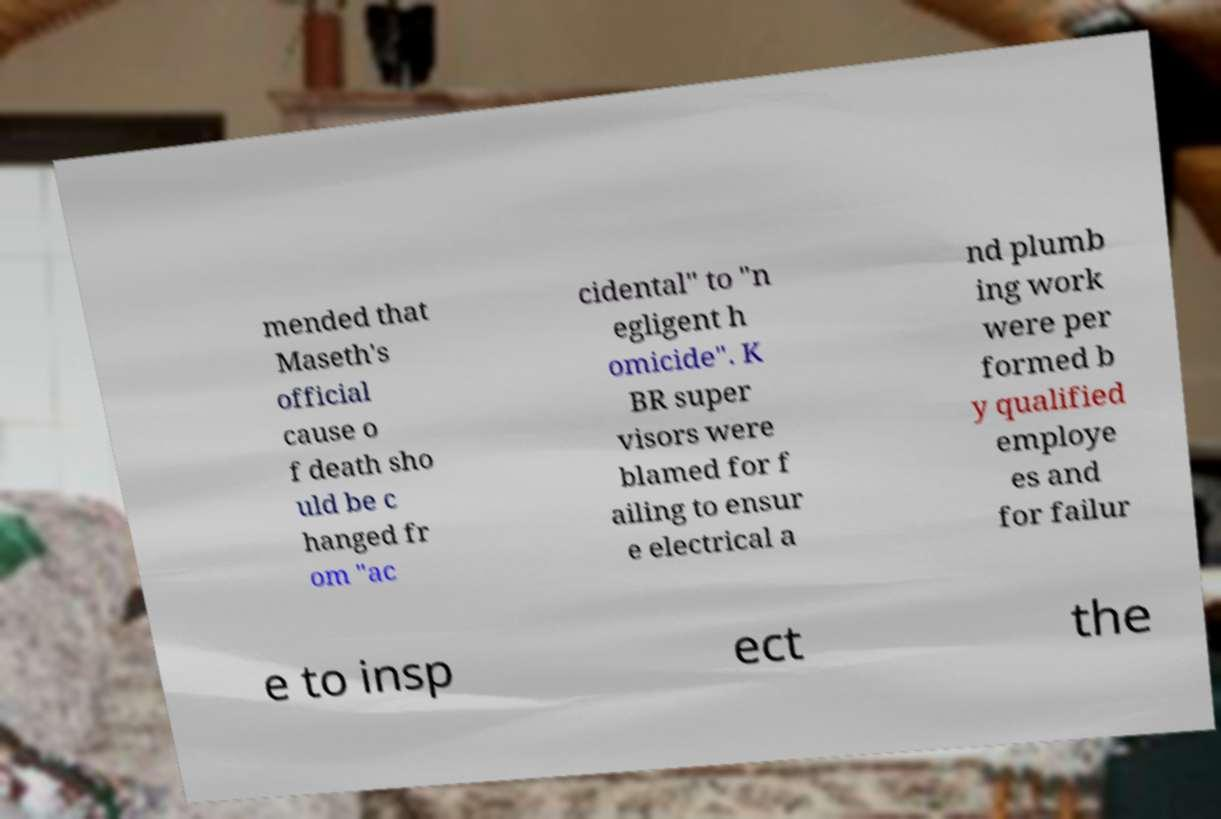Please read and relay the text visible in this image. What does it say? mended that Maseth's official cause o f death sho uld be c hanged fr om "ac cidental" to "n egligent h omicide". K BR super visors were blamed for f ailing to ensur e electrical a nd plumb ing work were per formed b y qualified employe es and for failur e to insp ect the 